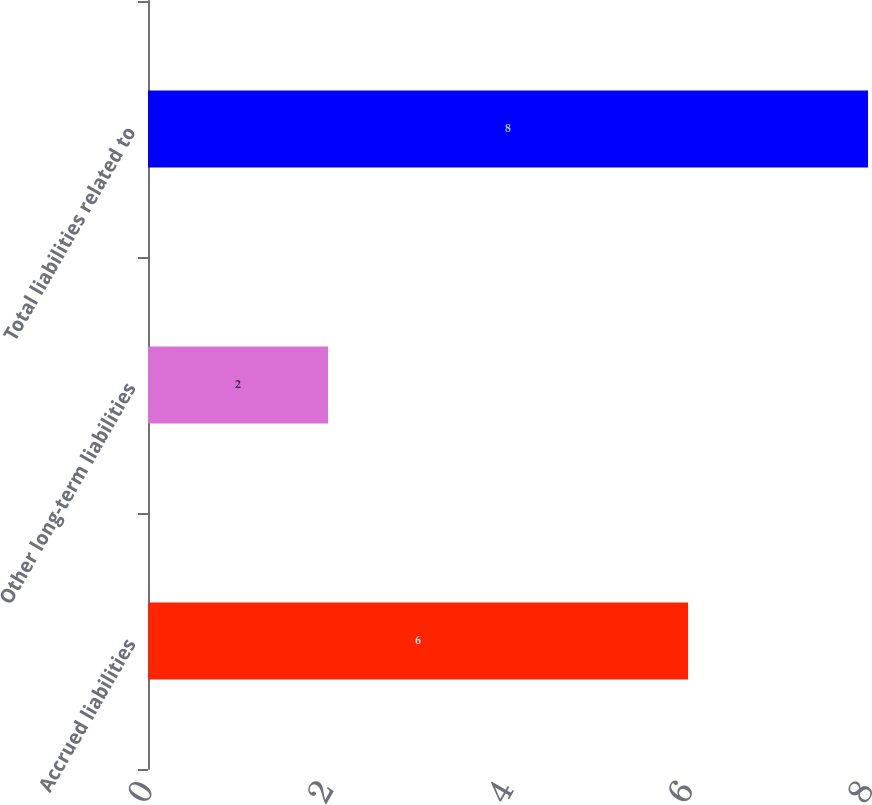<chart> <loc_0><loc_0><loc_500><loc_500><bar_chart><fcel>Accrued liabilities<fcel>Other long-term liabilities<fcel>Total liabilities related to<nl><fcel>6<fcel>2<fcel>8<nl></chart> 